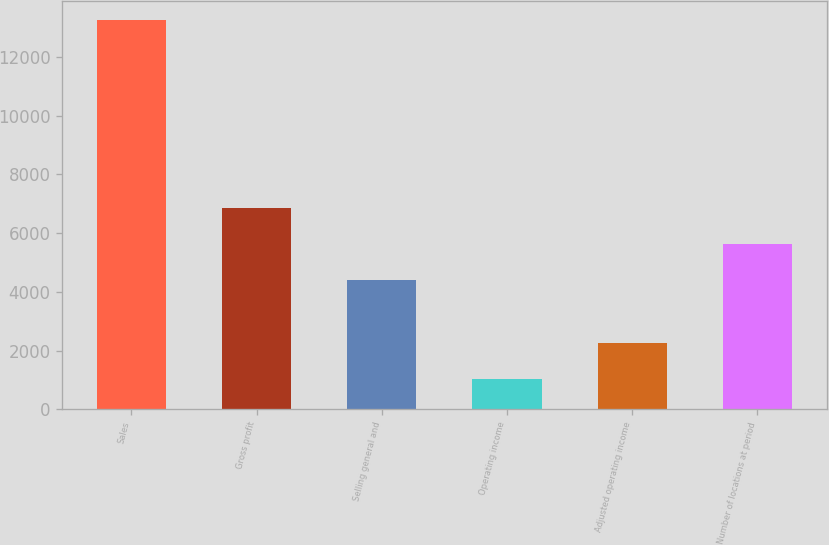Convert chart to OTSL. <chart><loc_0><loc_0><loc_500><loc_500><bar_chart><fcel>Sales<fcel>Gross profit<fcel>Selling general and<fcel>Operating income<fcel>Adjusted operating income<fcel>Number of locations at period<nl><fcel>13256<fcel>6848.4<fcel>4403<fcel>1029<fcel>2251.7<fcel>5625.7<nl></chart> 